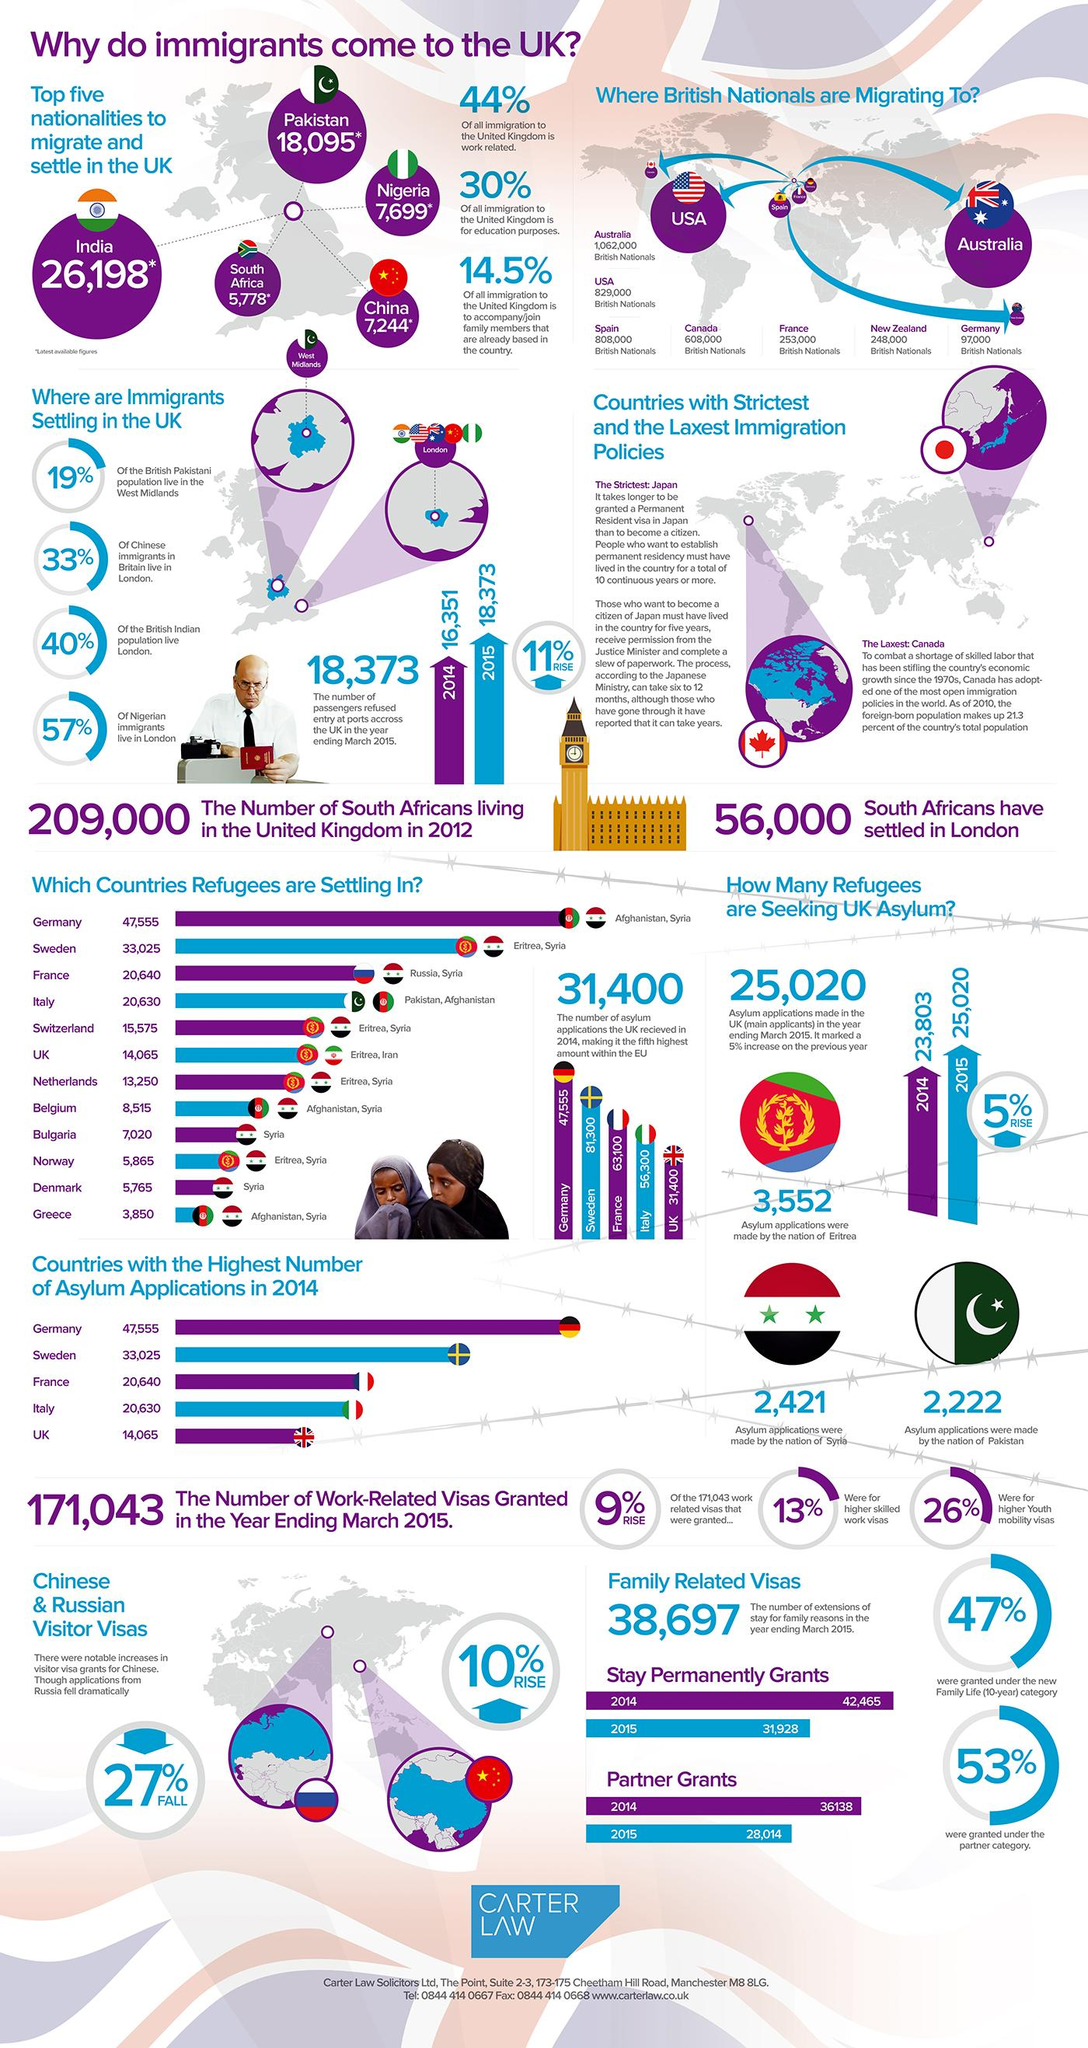Draw attention to some important aspects in this diagram. According to data, approximately 26.79% of South Africans living in London. According to the latest update, 7244 people migrated from China to the UK. The primary reason why people migrate to the UK from other countries is due to work-related opportunities. The citizens of India migrate to the UK the most among all countries. According to the provided information, more people from China have migrated to the United Kingdom than from Nigeria. 